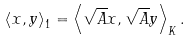Convert formula to latex. <formula><loc_0><loc_0><loc_500><loc_500>\left \langle x , y \right \rangle _ { 1 } = \left \langle \sqrt { A } x , \sqrt { A } y \right \rangle _ { K } .</formula> 